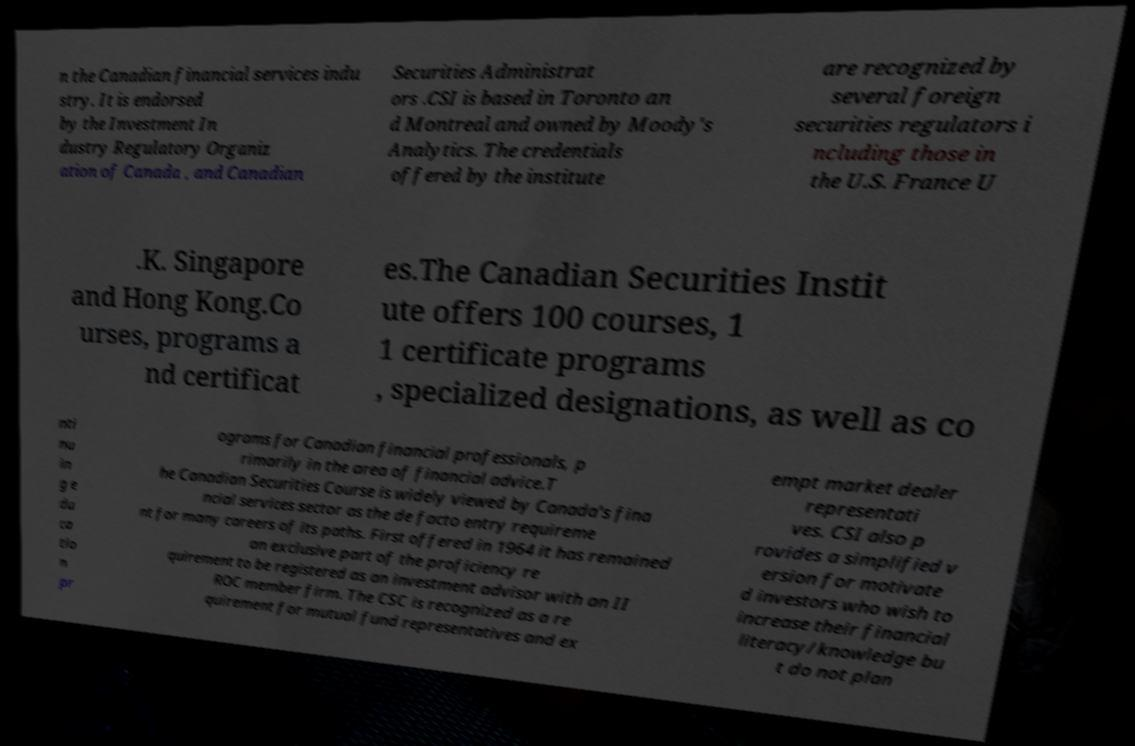Could you extract and type out the text from this image? n the Canadian financial services indu stry. It is endorsed by the Investment In dustry Regulatory Organiz ation of Canada , and Canadian Securities Administrat ors .CSI is based in Toronto an d Montreal and owned by Moody's Analytics. The credentials offered by the institute are recognized by several foreign securities regulators i ncluding those in the U.S. France U .K. Singapore and Hong Kong.Co urses, programs a nd certificat es.The Canadian Securities Instit ute offers 100 courses, 1 1 certificate programs , specialized designations, as well as co nti nu in g e du ca tio n pr ograms for Canadian financial professionals, p rimarily in the area of financial advice.T he Canadian Securities Course is widely viewed by Canada's fina ncial services sector as the de facto entry requireme nt for many careers of its paths. First offered in 1964 it has remained an exclusive part of the proficiency re quirement to be registered as an investment advisor with an II ROC member firm. The CSC is recognized as a re quirement for mutual fund representatives and ex empt market dealer representati ves. CSI also p rovides a simplified v ersion for motivate d investors who wish to increase their financial literacy/knowledge bu t do not plan 